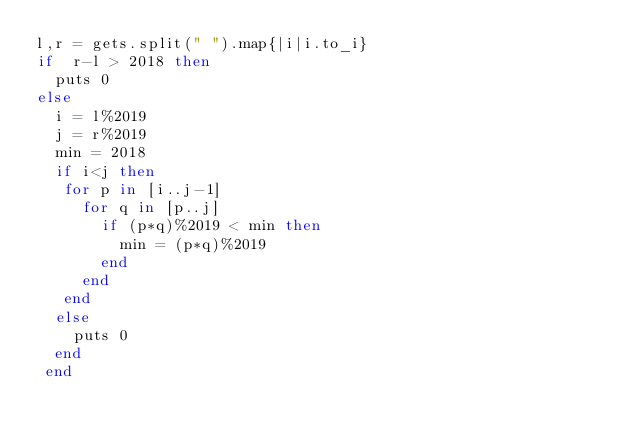Convert code to text. <code><loc_0><loc_0><loc_500><loc_500><_Ruby_>l,r = gets.split(" ").map{|i|i.to_i}
if  r-l > 2018 then
  puts 0
else
  i = l%2019
  j = r%2019
  min = 2018
  if i<j then
   for p in [i..j-1]
     for q in [p..j]
       if (p*q)%2019 < min then
         min = (p*q)%2019
       end
     end
   end
  else
    puts 0
  end
 end</code> 